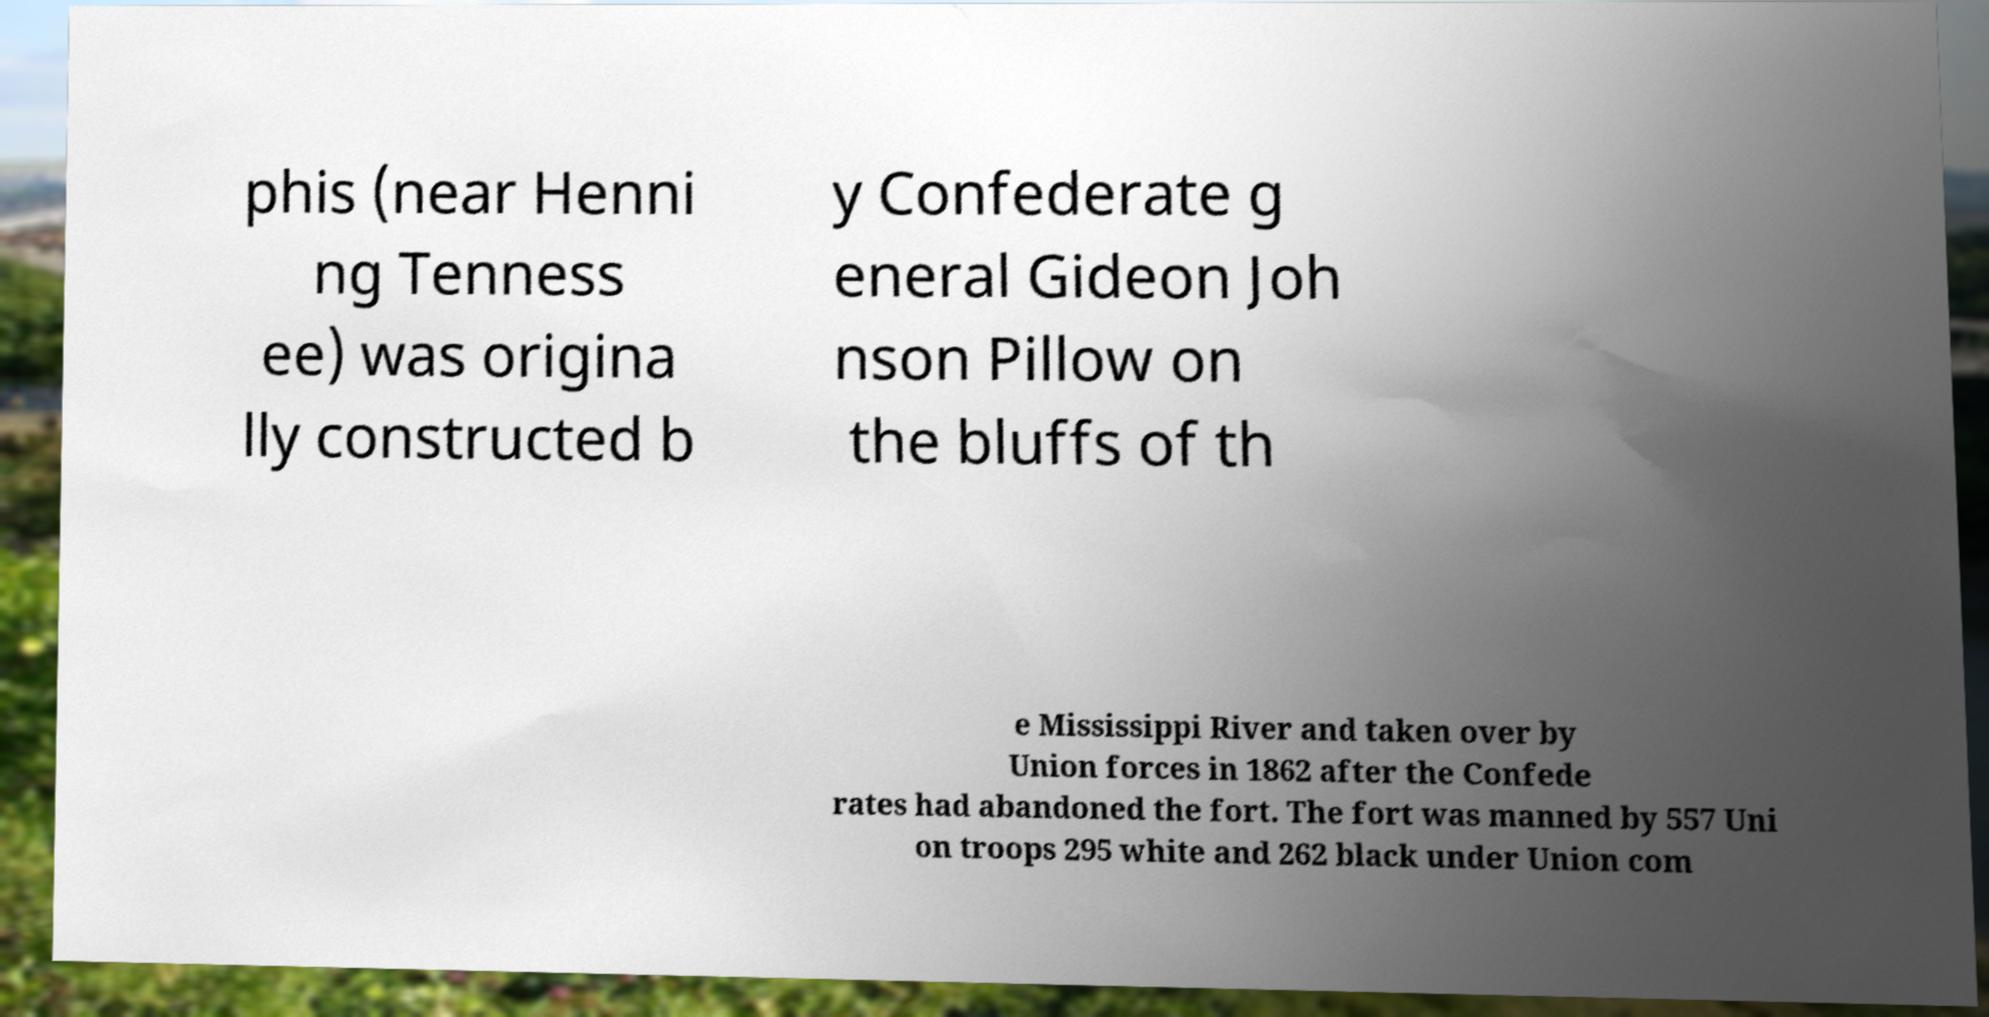For documentation purposes, I need the text within this image transcribed. Could you provide that? phis (near Henni ng Tenness ee) was origina lly constructed b y Confederate g eneral Gideon Joh nson Pillow on the bluffs of th e Mississippi River and taken over by Union forces in 1862 after the Confede rates had abandoned the fort. The fort was manned by 557 Uni on troops 295 white and 262 black under Union com 